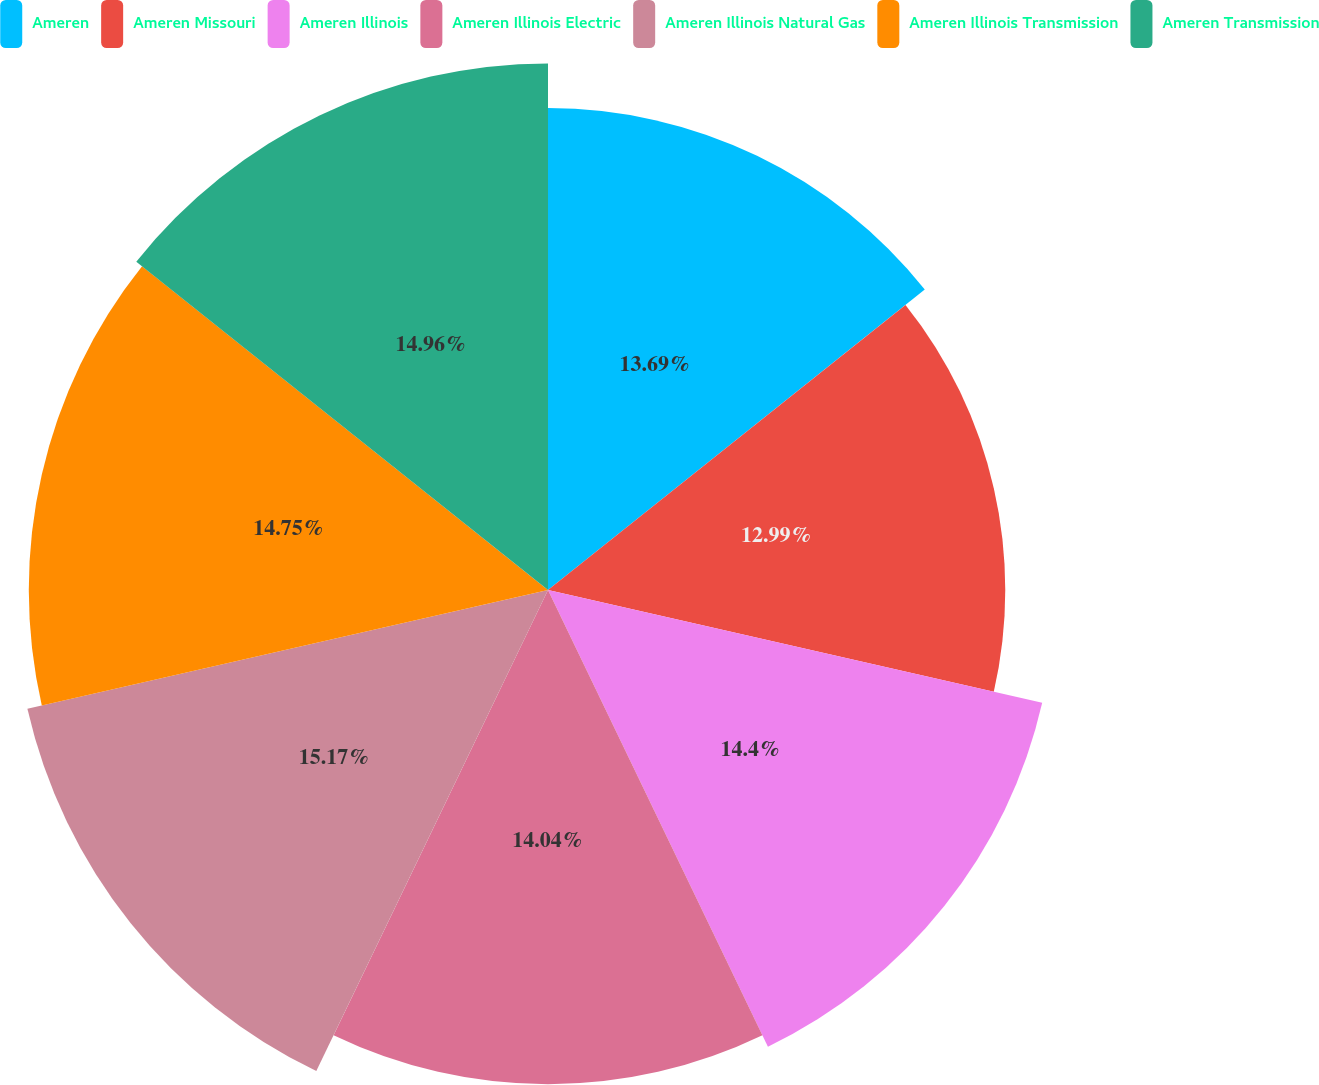Convert chart. <chart><loc_0><loc_0><loc_500><loc_500><pie_chart><fcel>Ameren<fcel>Ameren Missouri<fcel>Ameren Illinois<fcel>Ameren Illinois Electric<fcel>Ameren Illinois Natural Gas<fcel>Ameren Illinois Transmission<fcel>Ameren Transmission<nl><fcel>13.69%<fcel>12.99%<fcel>14.4%<fcel>14.04%<fcel>15.17%<fcel>14.75%<fcel>14.96%<nl></chart> 